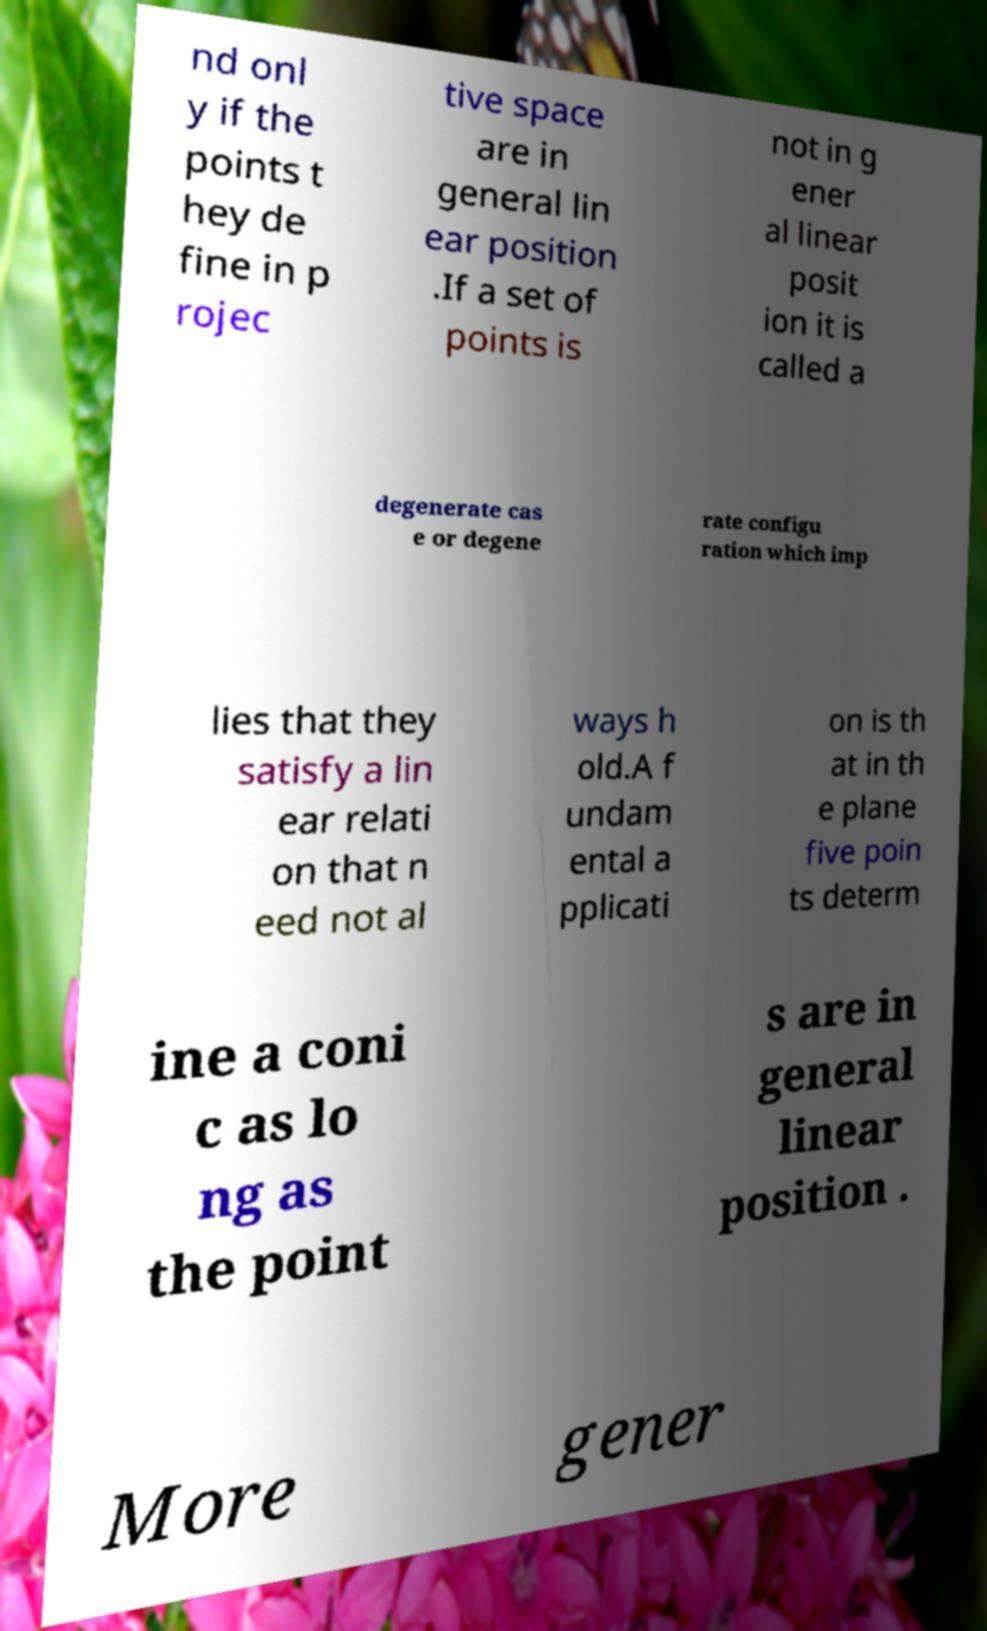Could you assist in decoding the text presented in this image and type it out clearly? nd onl y if the points t hey de fine in p rojec tive space are in general lin ear position .If a set of points is not in g ener al linear posit ion it is called a degenerate cas e or degene rate configu ration which imp lies that they satisfy a lin ear relati on that n eed not al ways h old.A f undam ental a pplicati on is th at in th e plane five poin ts determ ine a coni c as lo ng as the point s are in general linear position . More gener 